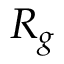<formula> <loc_0><loc_0><loc_500><loc_500>R _ { g }</formula> 